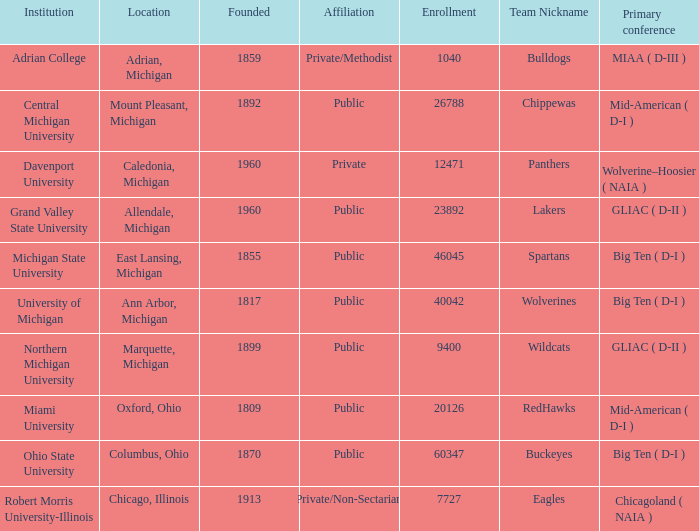Give me the full table as a dictionary. {'header': ['Institution', 'Location', 'Founded', 'Affiliation', 'Enrollment', 'Team Nickname', 'Primary conference'], 'rows': [['Adrian College', 'Adrian, Michigan', '1859', 'Private/Methodist', '1040', 'Bulldogs', 'MIAA ( D-III )'], ['Central Michigan University', 'Mount Pleasant, Michigan', '1892', 'Public', '26788', 'Chippewas', 'Mid-American ( D-I )'], ['Davenport University', 'Caledonia, Michigan', '1960', 'Private', '12471', 'Panthers', 'Wolverine–Hoosier ( NAIA )'], ['Grand Valley State University', 'Allendale, Michigan', '1960', 'Public', '23892', 'Lakers', 'GLIAC ( D-II )'], ['Michigan State University', 'East Lansing, Michigan', '1855', 'Public', '46045', 'Spartans', 'Big Ten ( D-I )'], ['University of Michigan', 'Ann Arbor, Michigan', '1817', 'Public', '40042', 'Wolverines', 'Big Ten ( D-I )'], ['Northern Michigan University', 'Marquette, Michigan', '1899', 'Public', '9400', 'Wildcats', 'GLIAC ( D-II )'], ['Miami University', 'Oxford, Ohio', '1809', 'Public', '20126', 'RedHawks', 'Mid-American ( D-I )'], ['Ohio State University', 'Columbus, Ohio', '1870', 'Public', '60347', 'Buckeyes', 'Big Ten ( D-I )'], ['Robert Morris University-Illinois', 'Chicago, Illinois', '1913', 'Private/Non-Sectarian', '7727', 'Eagles', 'Chicagoland ( NAIA )']]} What is the location of robert morris university-illinois? Chicago, Illinois. 